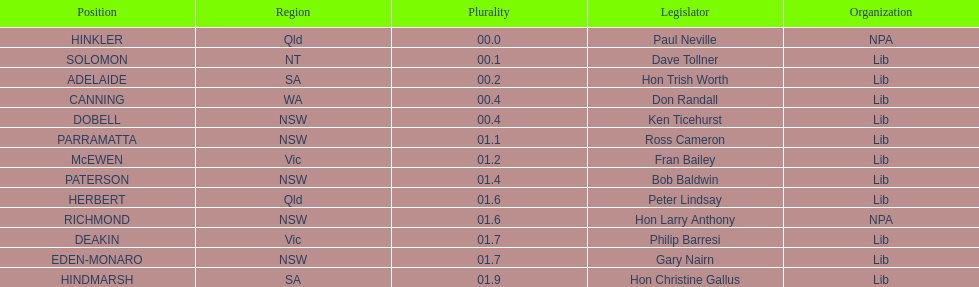What member comes next after hon trish worth? Don Randall. Can you parse all the data within this table? {'header': ['Position', 'Region', 'Plurality', 'Legislator', 'Organization'], 'rows': [['HINKLER', 'Qld', '00.0', 'Paul Neville', 'NPA'], ['SOLOMON', 'NT', '00.1', 'Dave Tollner', 'Lib'], ['ADELAIDE', 'SA', '00.2', 'Hon Trish Worth', 'Lib'], ['CANNING', 'WA', '00.4', 'Don Randall', 'Lib'], ['DOBELL', 'NSW', '00.4', 'Ken Ticehurst', 'Lib'], ['PARRAMATTA', 'NSW', '01.1', 'Ross Cameron', 'Lib'], ['McEWEN', 'Vic', '01.2', 'Fran Bailey', 'Lib'], ['PATERSON', 'NSW', '01.4', 'Bob Baldwin', 'Lib'], ['HERBERT', 'Qld', '01.6', 'Peter Lindsay', 'Lib'], ['RICHMOND', 'NSW', '01.6', 'Hon Larry Anthony', 'NPA'], ['DEAKIN', 'Vic', '01.7', 'Philip Barresi', 'Lib'], ['EDEN-MONARO', 'NSW', '01.7', 'Gary Nairn', 'Lib'], ['HINDMARSH', 'SA', '01.9', 'Hon Christine Gallus', 'Lib']]} 